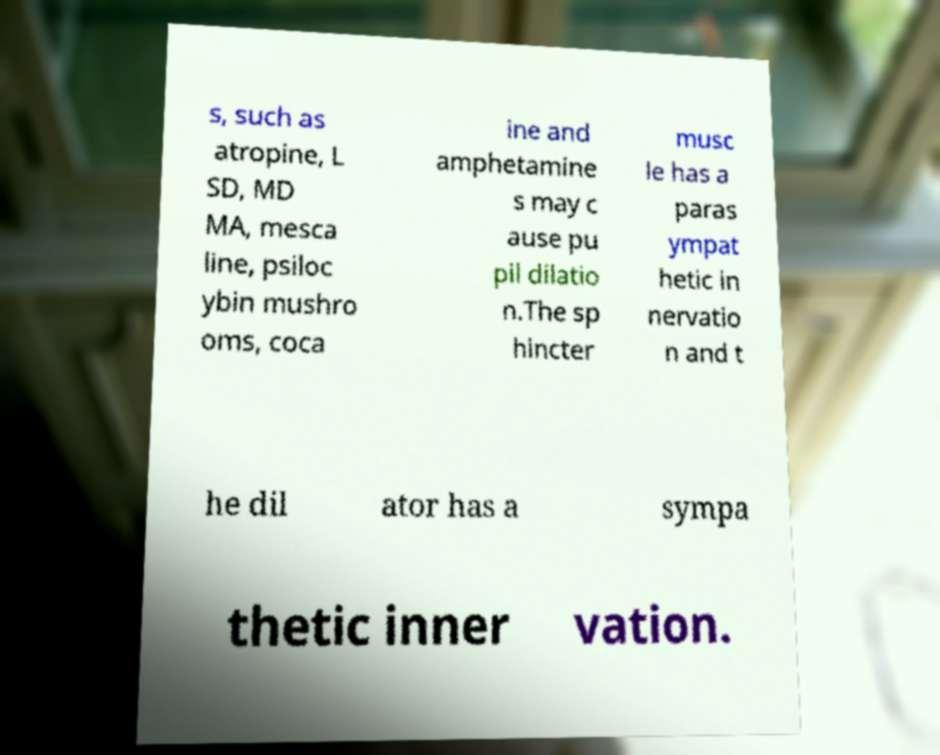Can you accurately transcribe the text from the provided image for me? s, such as atropine, L SD, MD MA, mesca line, psiloc ybin mushro oms, coca ine and amphetamine s may c ause pu pil dilatio n.The sp hincter musc le has a paras ympat hetic in nervatio n and t he dil ator has a sympa thetic inner vation. 